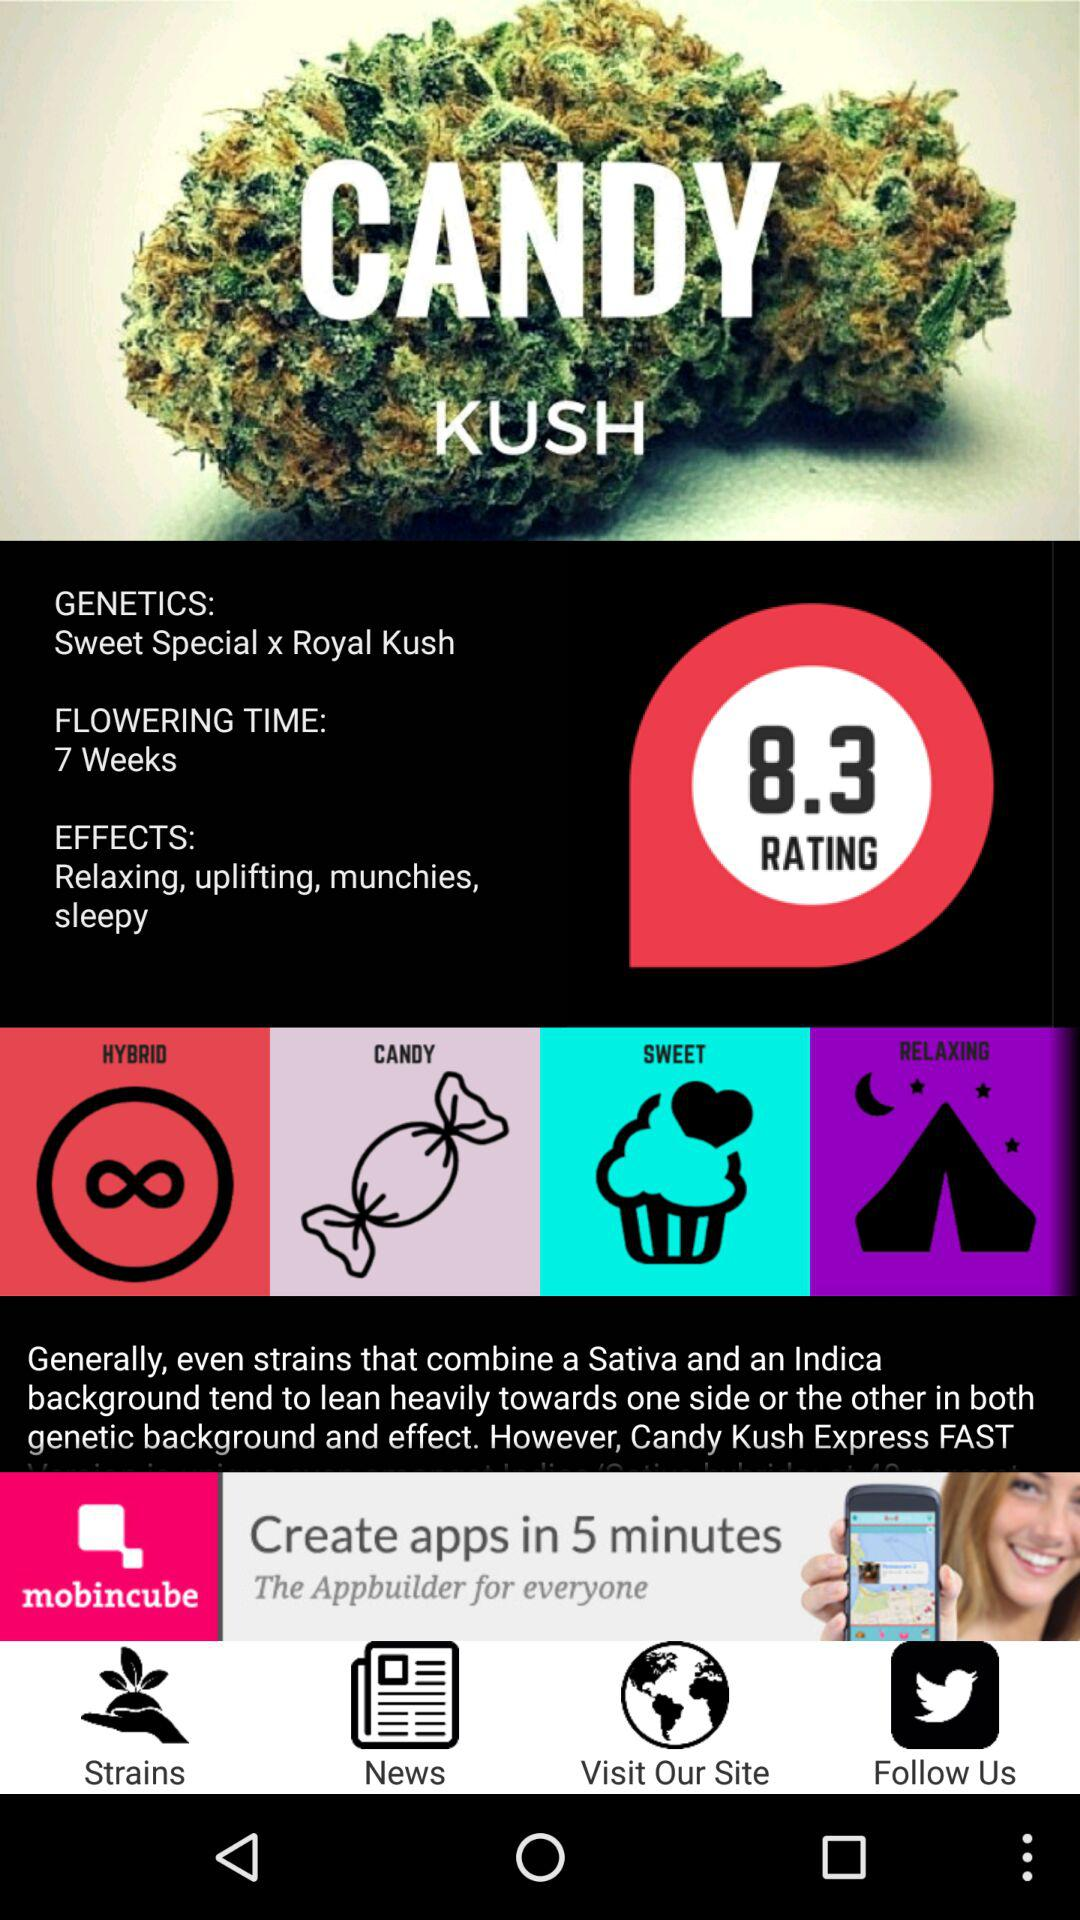What is the flowering time? The flowering time is 7 weeks. 